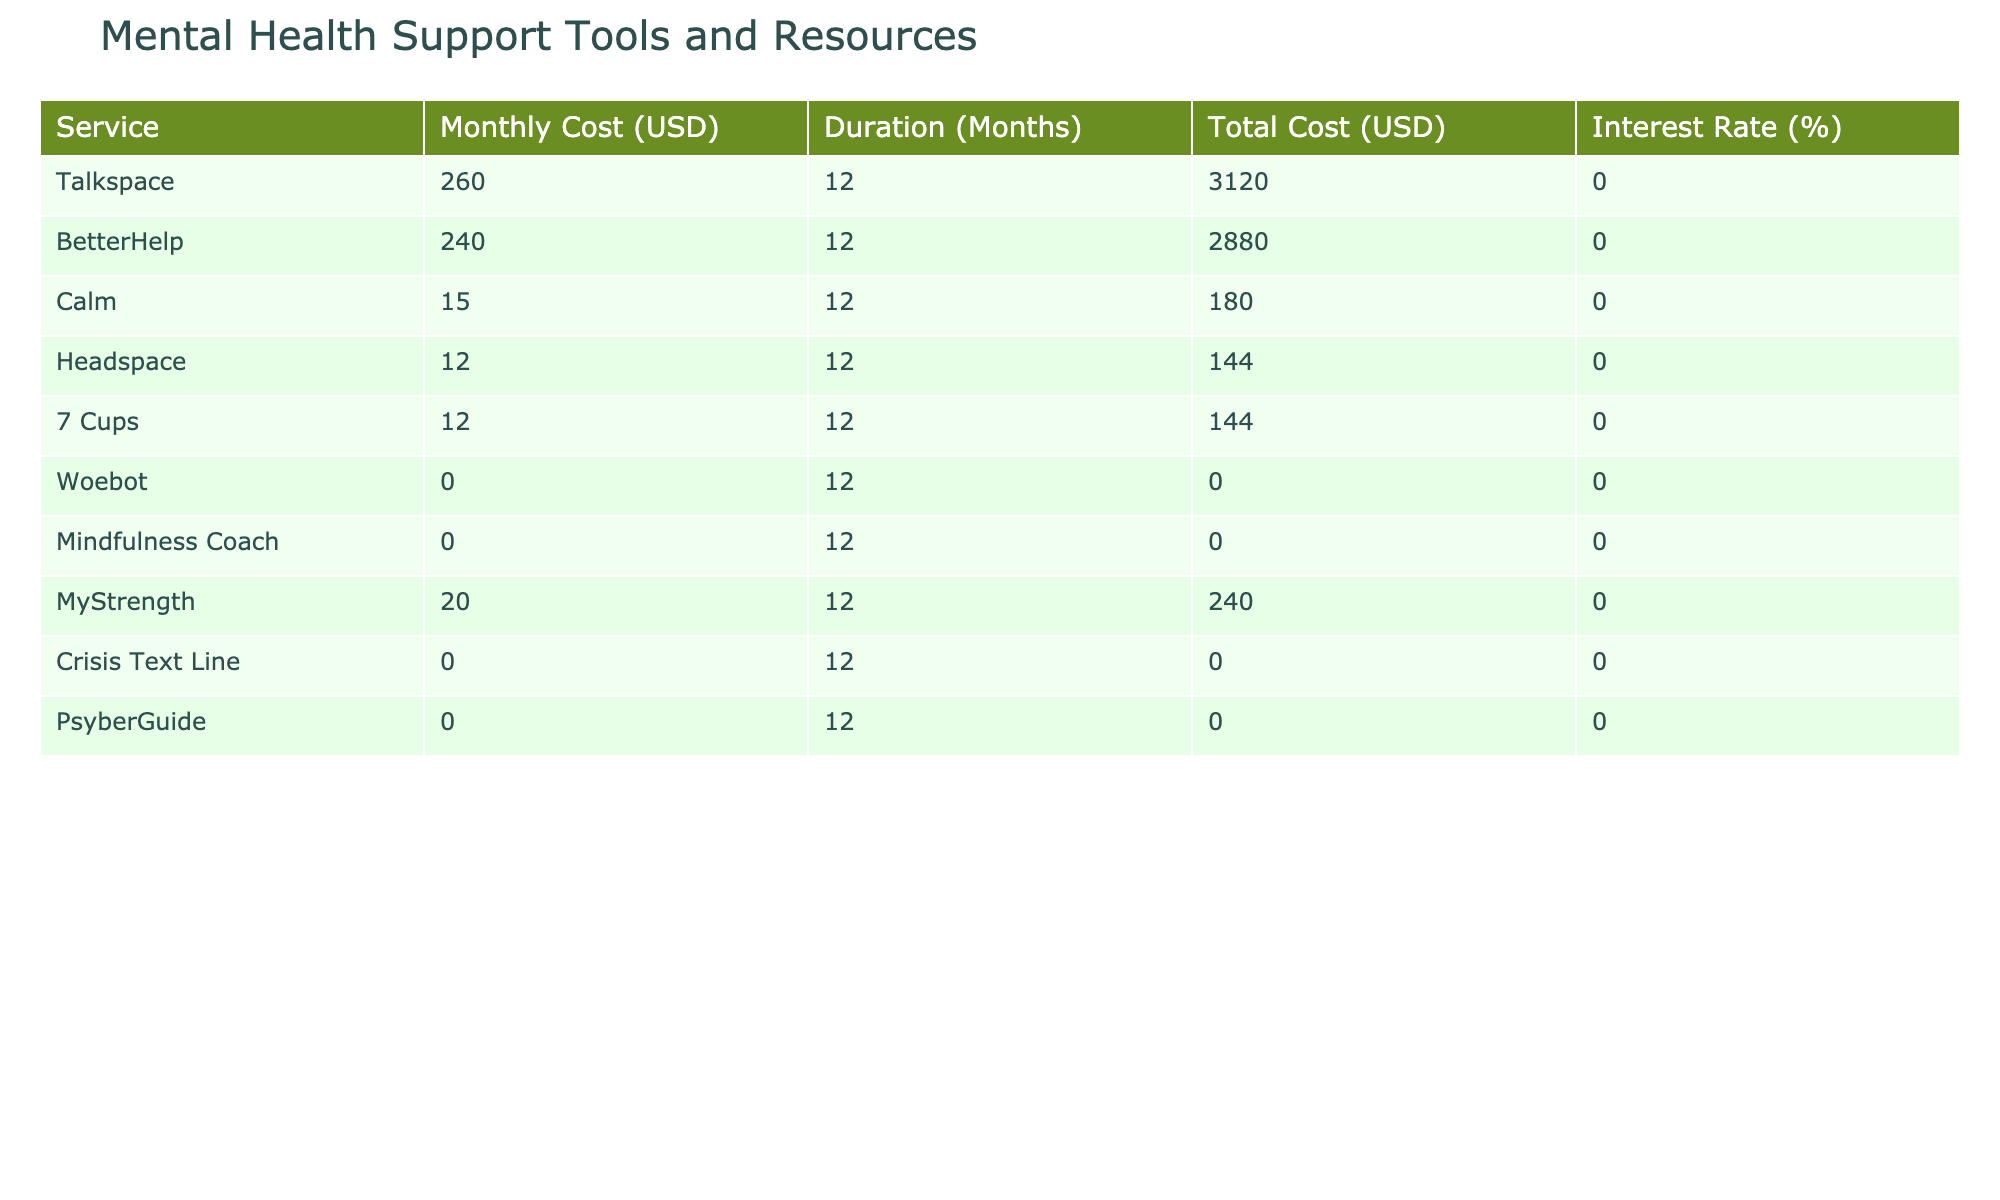What is the total cost of the Talkspace service for 12 months? The table states that the total cost for the Talkspace service over a 12-month period is listed as 3120 USD.
Answer: 3120 USD What is the monthly cost of BetterHelp? Referring to the table, the monthly cost for BetterHelp is shown to be 240 USD.
Answer: 240 USD How much does Woebot cost for 12 months? According to the table, the total cost for Woebot over 12 months is 0 USD, which indicates it is free.
Answer: 0 USD Which service has the lowest monthly cost? By examining the monthly costs, Calm has the lowest cost at 15 USD.
Answer: 15 USD What is the average monthly cost of all services listed? The total monthly costs are (260 + 240 + 15 + 12 + 12 + 12 + 0 + 0 + 20 + 0) = 569 USD, and there are 10 services, so the average is 569/10 = 56.9 USD.
Answer: 56.9 USD Is the total cost for the Crisis Text Line service greater than 100 USD? Looking at the table, the total cost for the Crisis Text Line is 0 USD, which is not greater than 100 USD.
Answer: No How much more does Talkspace cost compared to Headspace? The total cost for Talkspace is 3120 USD, and for Headspace, it is 144 USD. The difference is 3120 - 144 = 2976 USD.
Answer: 2976 USD How many services are offered at no cost? By checking the table, it shows that Woebot, Mindfulness Coach, Crisis Text Line, and PsyberGuide are all free services, making it a total of 4 services.
Answer: 4 services What is the total cost of all services combined over a 12-month period? Summing the total costs from the table gives: 3120 (Talkspace) + 2880 (BetterHelp) + 180 (Calm) + 144 (Headspace) + 144 (7 Cups) + 0 (Woebot) + 0 (Mindfulness Coach) + 240 (MyStrength) + 0 (Crisis Text Line) + 0 (PsyberGuide) = 3608 USD.
Answer: 3608 USD 